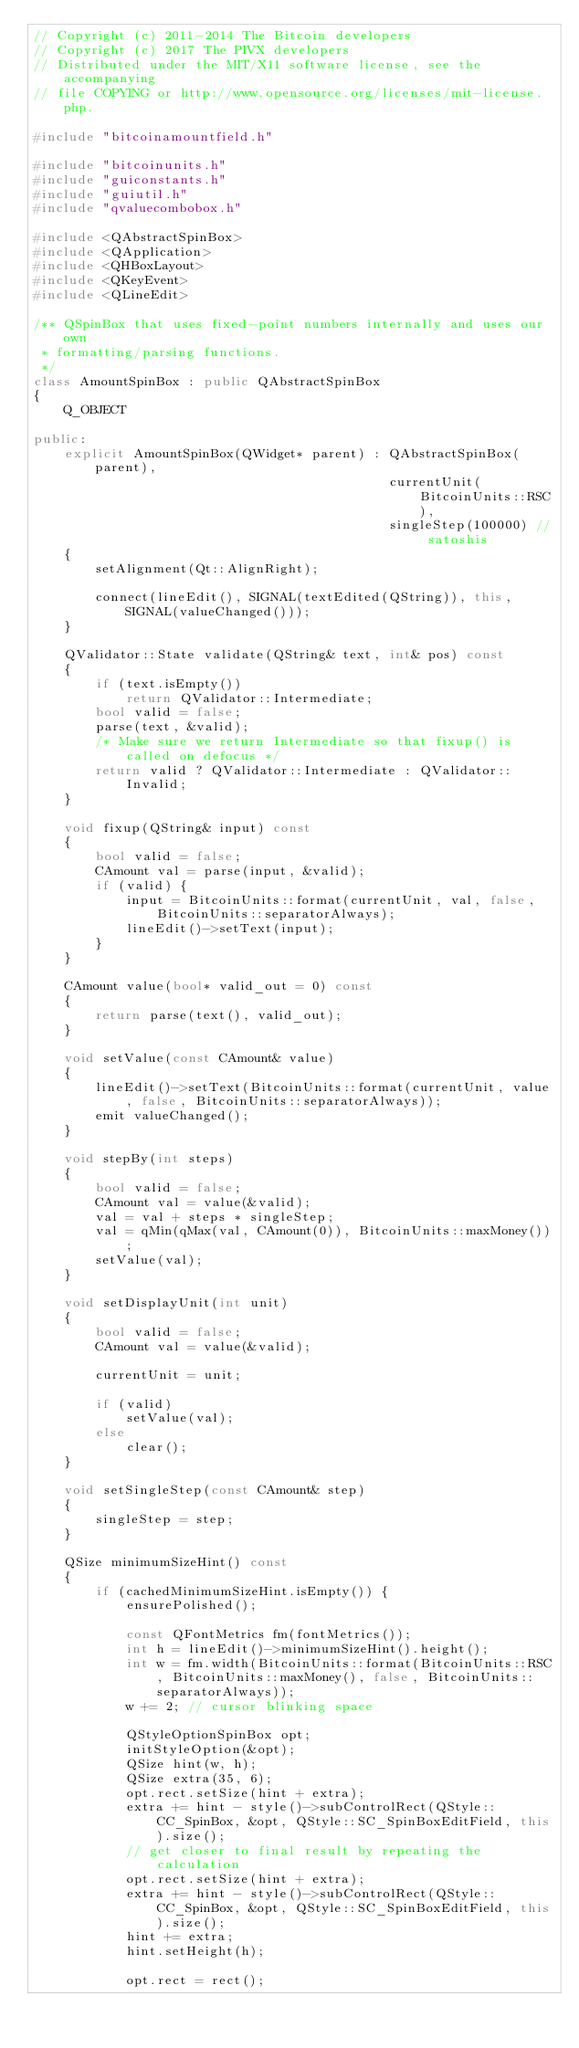Convert code to text. <code><loc_0><loc_0><loc_500><loc_500><_C++_>// Copyright (c) 2011-2014 The Bitcoin developers
// Copyright (c) 2017 The PIVX developers
// Distributed under the MIT/X11 software license, see the accompanying
// file COPYING or http://www.opensource.org/licenses/mit-license.php.

#include "bitcoinamountfield.h"

#include "bitcoinunits.h"
#include "guiconstants.h"
#include "guiutil.h"
#include "qvaluecombobox.h"

#include <QAbstractSpinBox>
#include <QApplication>
#include <QHBoxLayout>
#include <QKeyEvent>
#include <QLineEdit>

/** QSpinBox that uses fixed-point numbers internally and uses our own
 * formatting/parsing functions.
 */
class AmountSpinBox : public QAbstractSpinBox
{
    Q_OBJECT

public:
    explicit AmountSpinBox(QWidget* parent) : QAbstractSpinBox(parent),
                                              currentUnit(BitcoinUnits::RSC),
                                              singleStep(100000) // satoshis
    {
        setAlignment(Qt::AlignRight);

        connect(lineEdit(), SIGNAL(textEdited(QString)), this, SIGNAL(valueChanged()));
    }

    QValidator::State validate(QString& text, int& pos) const
    {
        if (text.isEmpty())
            return QValidator::Intermediate;
        bool valid = false;
        parse(text, &valid);
        /* Make sure we return Intermediate so that fixup() is called on defocus */
        return valid ? QValidator::Intermediate : QValidator::Invalid;
    }

    void fixup(QString& input) const
    {
        bool valid = false;
        CAmount val = parse(input, &valid);
        if (valid) {
            input = BitcoinUnits::format(currentUnit, val, false, BitcoinUnits::separatorAlways);
            lineEdit()->setText(input);
        }
    }

    CAmount value(bool* valid_out = 0) const
    {
        return parse(text(), valid_out);
    }

    void setValue(const CAmount& value)
    {
        lineEdit()->setText(BitcoinUnits::format(currentUnit, value, false, BitcoinUnits::separatorAlways));
        emit valueChanged();
    }

    void stepBy(int steps)
    {
        bool valid = false;
        CAmount val = value(&valid);
        val = val + steps * singleStep;
        val = qMin(qMax(val, CAmount(0)), BitcoinUnits::maxMoney());
        setValue(val);
    }

    void setDisplayUnit(int unit)
    {
        bool valid = false;
        CAmount val = value(&valid);

        currentUnit = unit;

        if (valid)
            setValue(val);
        else
            clear();
    }

    void setSingleStep(const CAmount& step)
    {
        singleStep = step;
    }

    QSize minimumSizeHint() const
    {
        if (cachedMinimumSizeHint.isEmpty()) {
            ensurePolished();

            const QFontMetrics fm(fontMetrics());
            int h = lineEdit()->minimumSizeHint().height();
            int w = fm.width(BitcoinUnits::format(BitcoinUnits::RSC, BitcoinUnits::maxMoney(), false, BitcoinUnits::separatorAlways));
            w += 2; // cursor blinking space

            QStyleOptionSpinBox opt;
            initStyleOption(&opt);
            QSize hint(w, h);
            QSize extra(35, 6);
            opt.rect.setSize(hint + extra);
            extra += hint - style()->subControlRect(QStyle::CC_SpinBox, &opt, QStyle::SC_SpinBoxEditField, this).size();
            // get closer to final result by repeating the calculation
            opt.rect.setSize(hint + extra);
            extra += hint - style()->subControlRect(QStyle::CC_SpinBox, &opt, QStyle::SC_SpinBoxEditField, this).size();
            hint += extra;
            hint.setHeight(h);

            opt.rect = rect();
</code> 